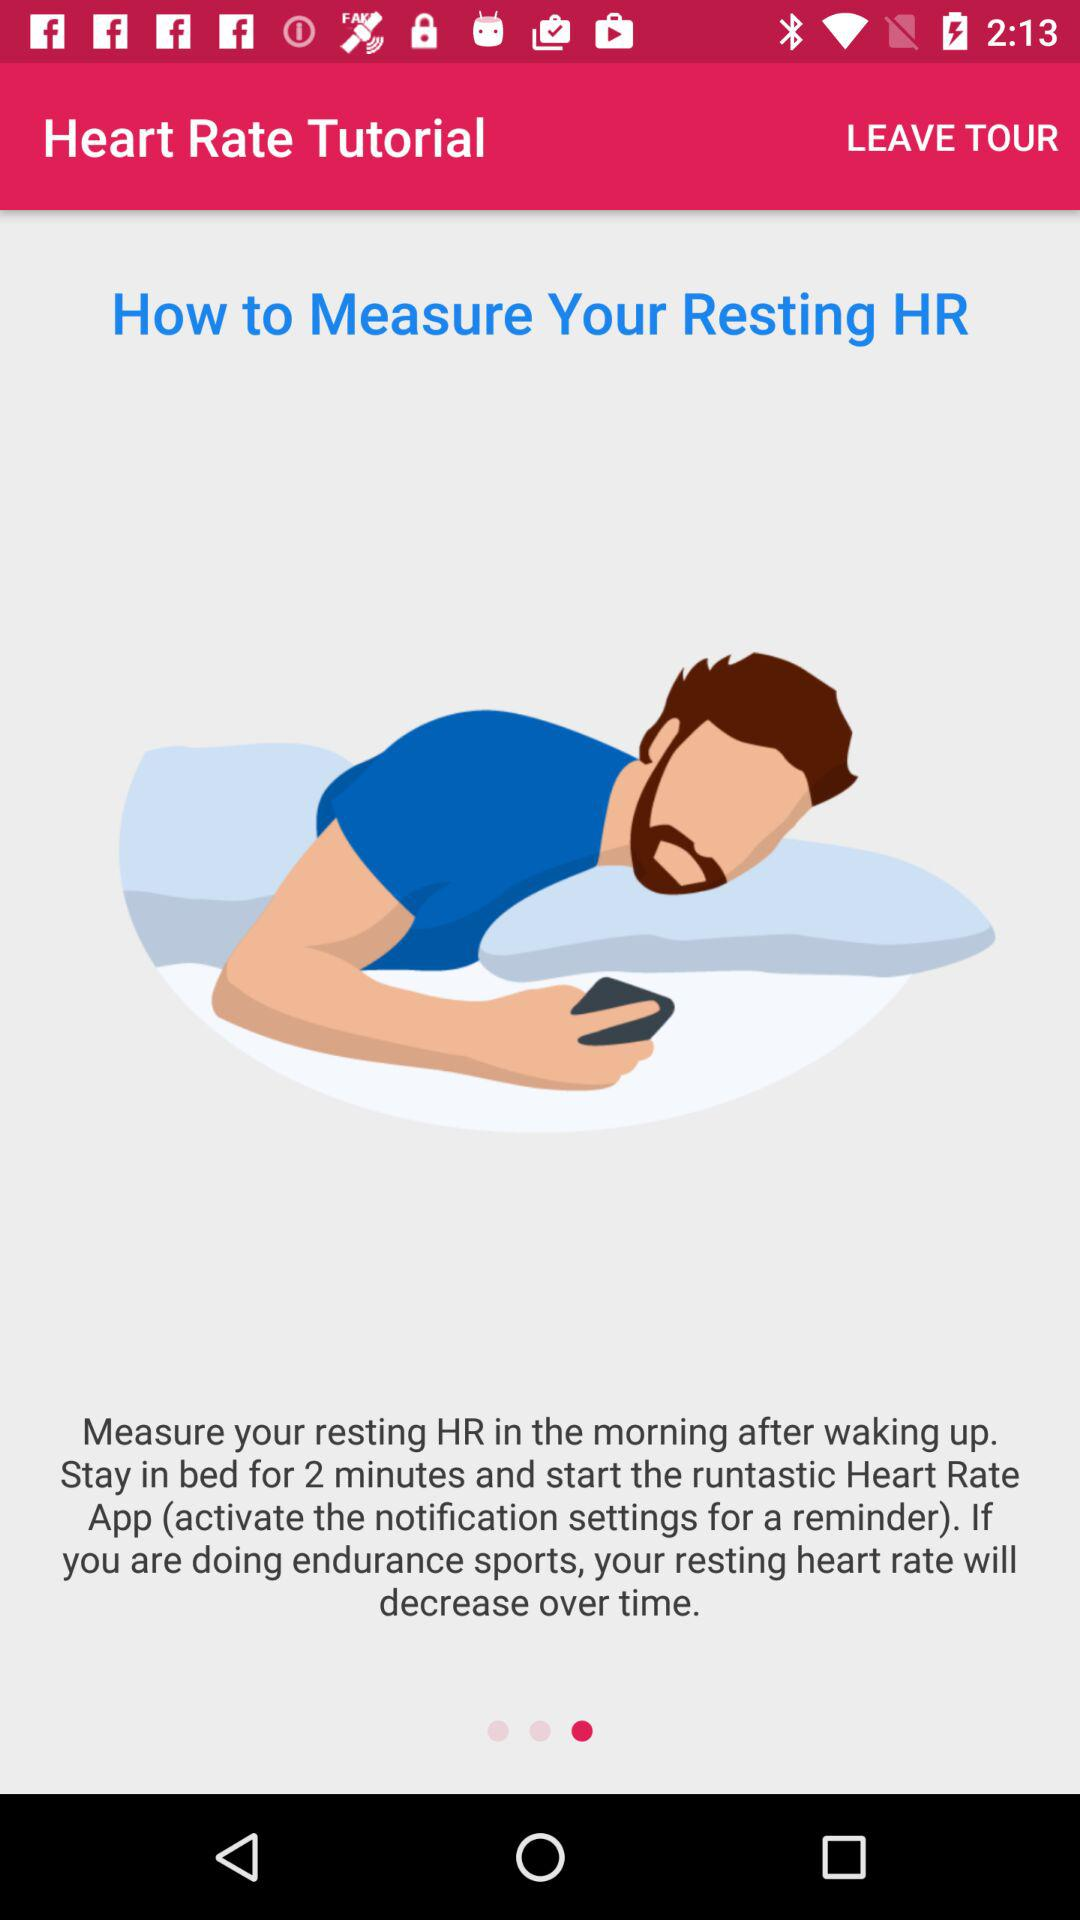What is the name of the application? The application name is "Heart Rate Tutorial". 